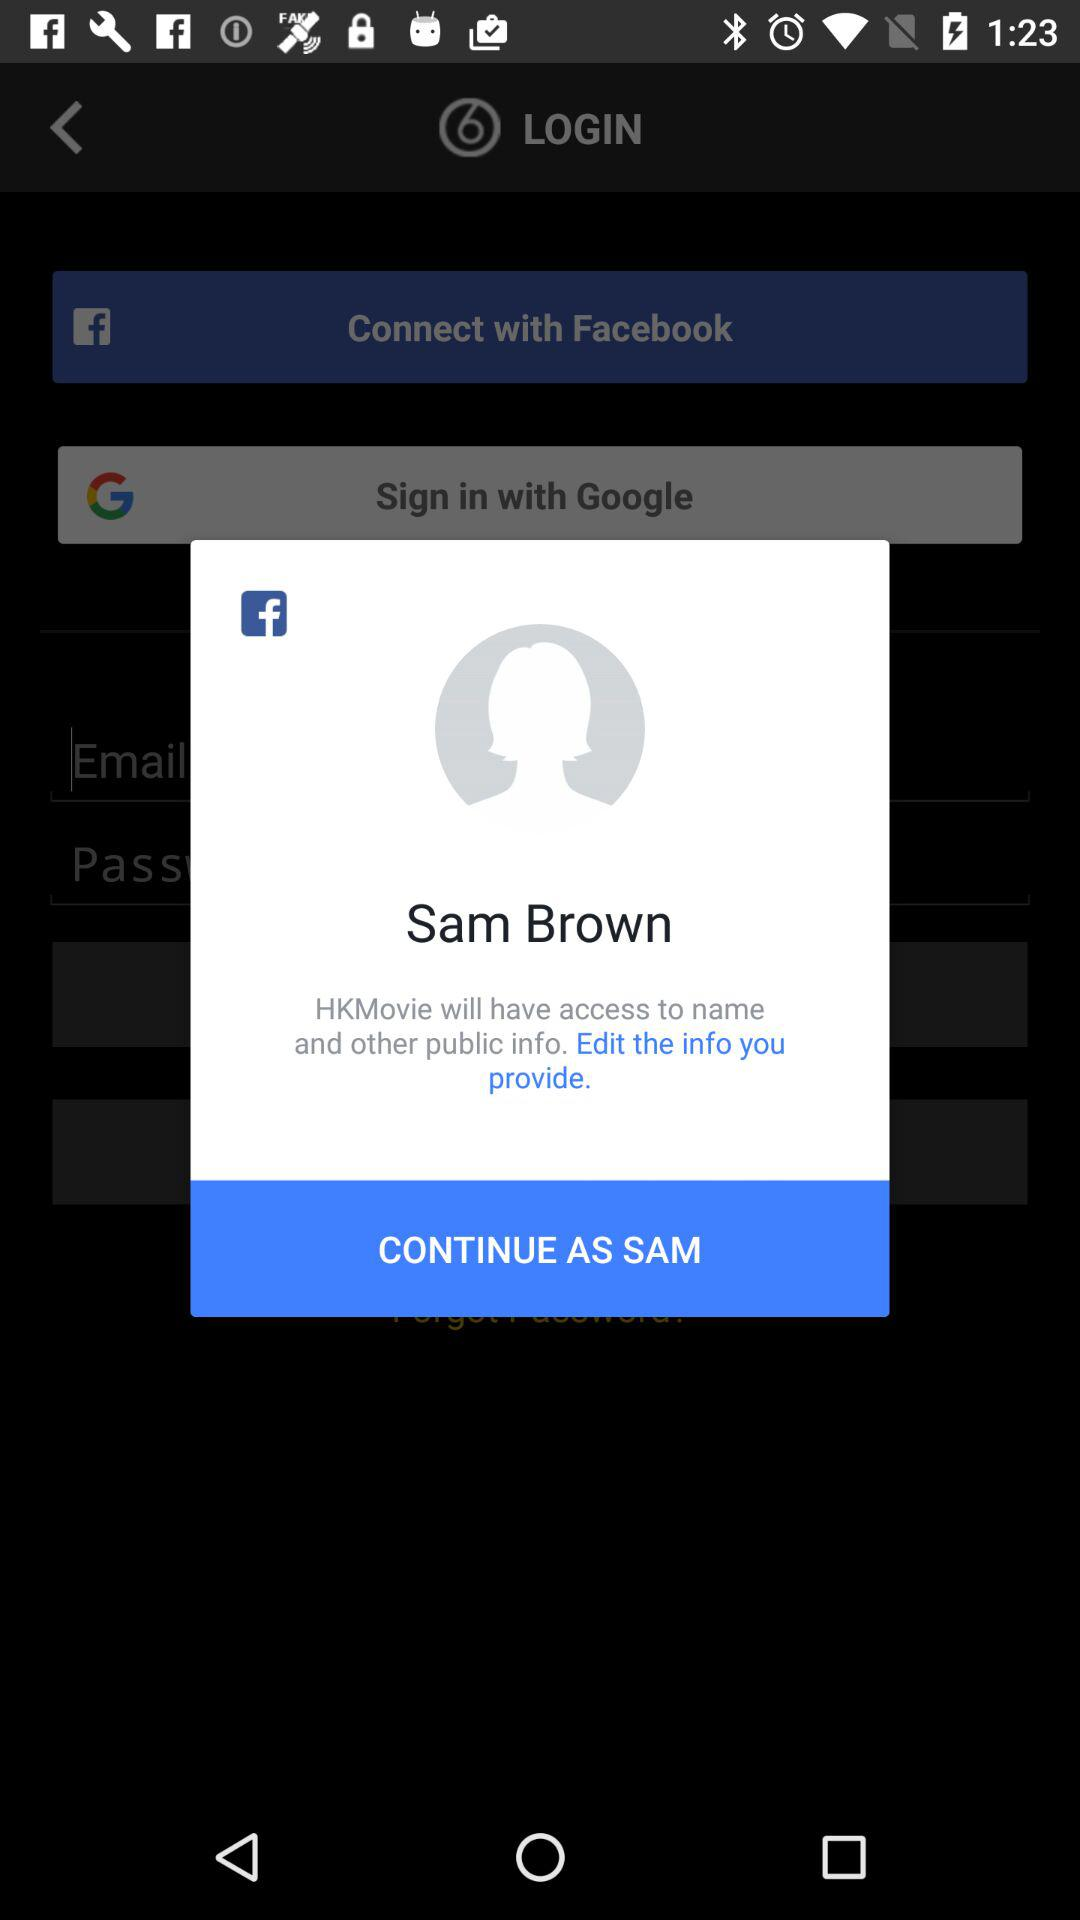What is the user name? The user name is Sam Brown. 